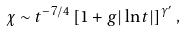Convert formula to latex. <formula><loc_0><loc_0><loc_500><loc_500>\chi \sim t ^ { - 7 / 4 } \left [ 1 + g | \ln t | \right ] ^ { \gamma ^ { \prime } } ,</formula> 